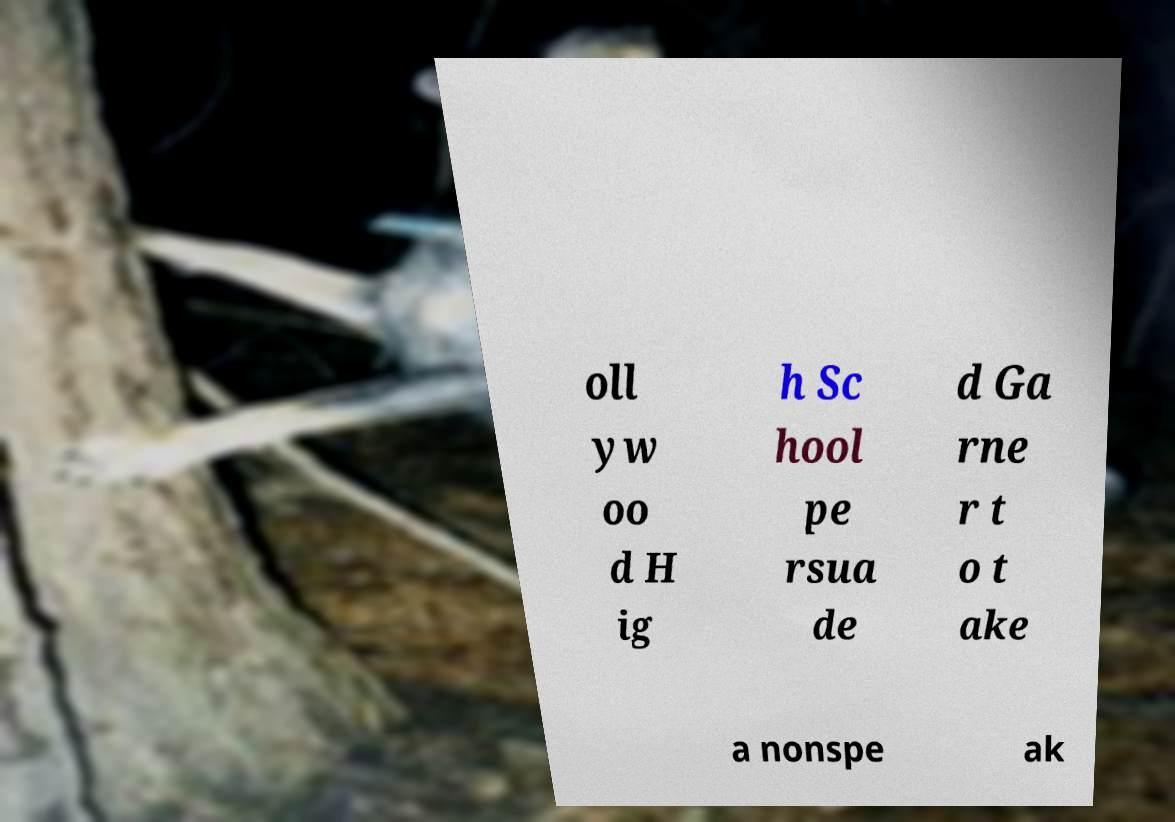Could you assist in decoding the text presented in this image and type it out clearly? oll yw oo d H ig h Sc hool pe rsua de d Ga rne r t o t ake a nonspe ak 